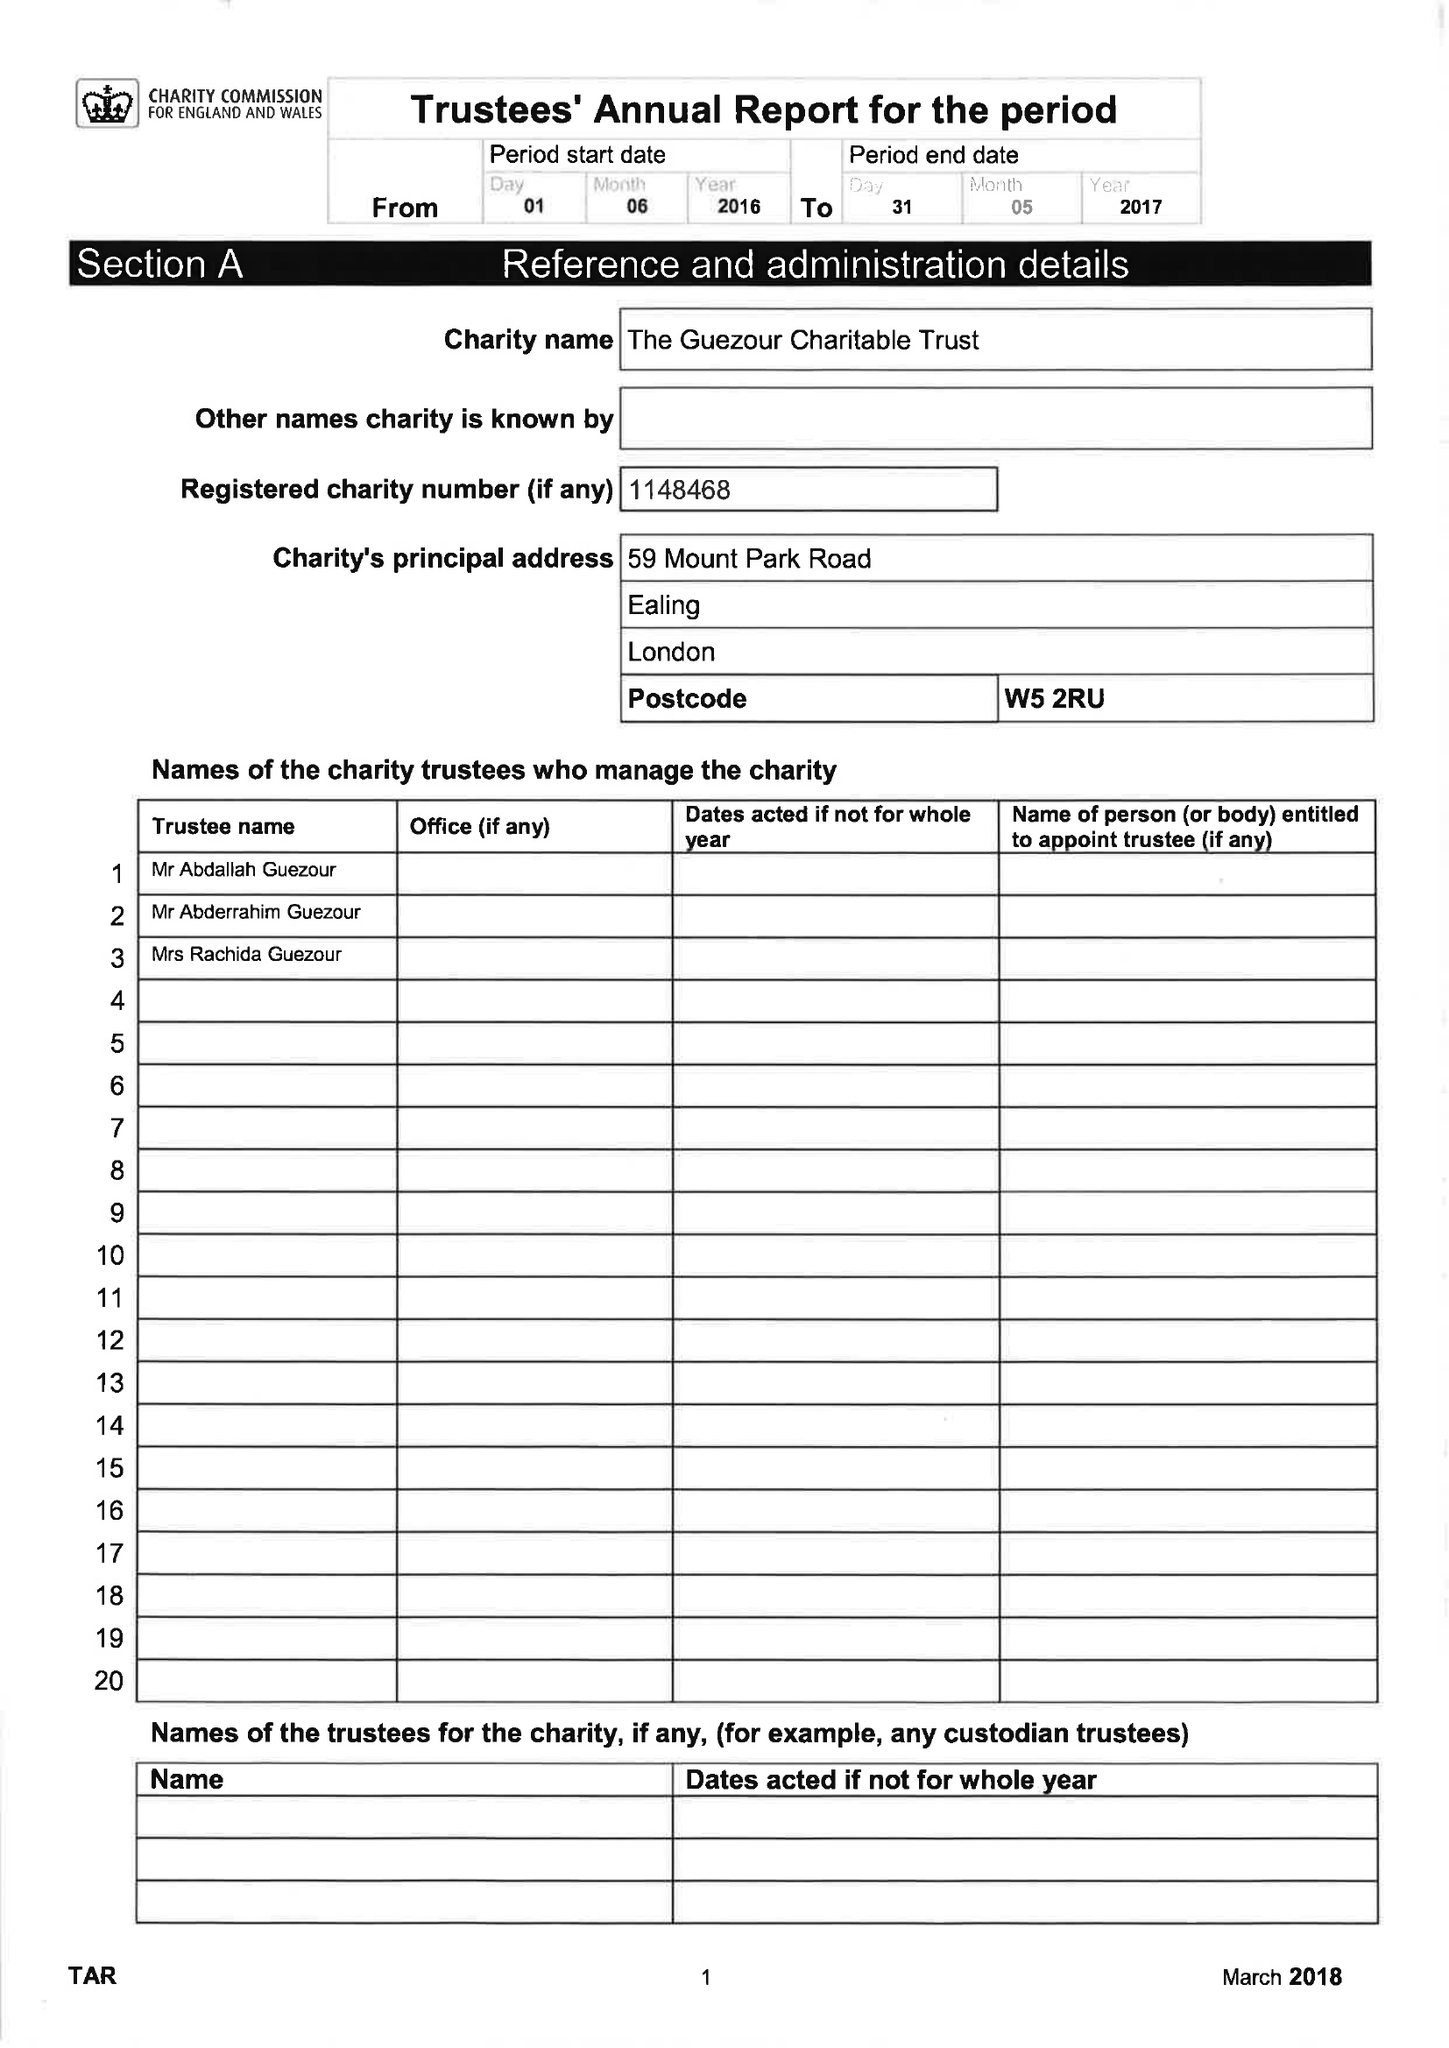What is the value for the income_annually_in_british_pounds?
Answer the question using a single word or phrase. 200481.00 